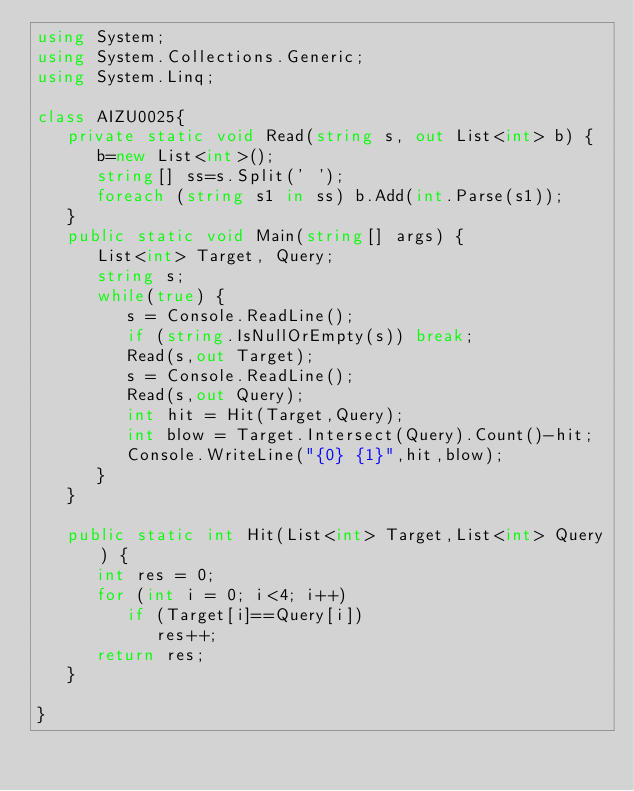Convert code to text. <code><loc_0><loc_0><loc_500><loc_500><_C#_>using System;
using System.Collections.Generic;
using System.Linq;

class AIZU0025{
   private static void Read(string s, out List<int> b) {
      b=new List<int>();
      string[] ss=s.Split(' ');
      foreach (string s1 in ss) b.Add(int.Parse(s1));
   }
   public static void Main(string[] args) {
      List<int> Target, Query;
      string s;
      while(true) { 
         s = Console.ReadLine();
         if (string.IsNullOrEmpty(s)) break;
         Read(s,out Target);
         s = Console.ReadLine();
         Read(s,out Query);
         int hit = Hit(Target,Query);
         int blow = Target.Intersect(Query).Count()-hit;
         Console.WriteLine("{0} {1}",hit,blow);
      }
   }

   public static int Hit(List<int> Target,List<int> Query) {
      int res = 0;
      for (int i = 0; i<4; i++)
         if (Target[i]==Query[i]) 
            res++;
      return res;
   }

}</code> 